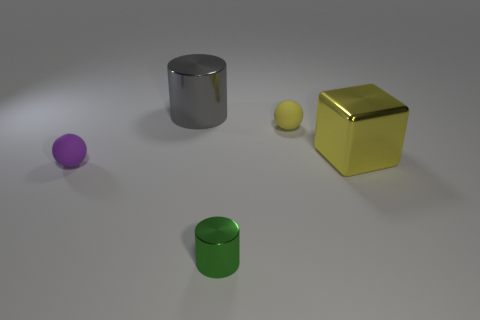Add 1 gray shiny objects. How many objects exist? 6 Subtract all cubes. How many objects are left? 4 Add 4 small yellow matte spheres. How many small yellow matte spheres are left? 5 Add 5 big blocks. How many big blocks exist? 6 Subtract 0 blue cylinders. How many objects are left? 5 Subtract all metal objects. Subtract all small green things. How many objects are left? 1 